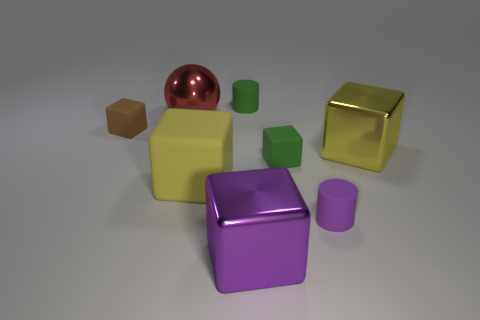Subtract all tiny rubber blocks. How many blocks are left? 3 Subtract all red spheres. How many yellow blocks are left? 2 Subtract all brown cubes. How many cubes are left? 4 Add 2 big yellow shiny objects. How many objects exist? 10 Subtract 2 cubes. How many cubes are left? 3 Subtract all cylinders. How many objects are left? 6 Subtract 0 cyan cylinders. How many objects are left? 8 Subtract all yellow blocks. Subtract all brown cylinders. How many blocks are left? 3 Subtract all small green rubber cylinders. Subtract all big yellow objects. How many objects are left? 5 Add 3 small green cylinders. How many small green cylinders are left? 4 